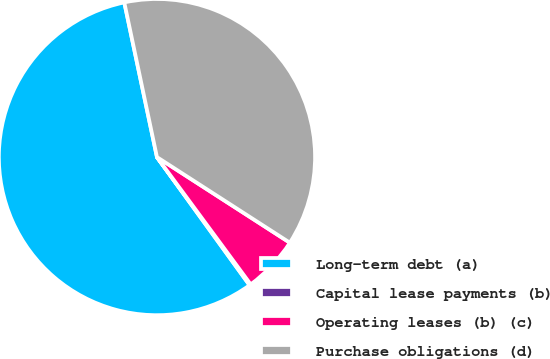Convert chart. <chart><loc_0><loc_0><loc_500><loc_500><pie_chart><fcel>Long-term debt (a)<fcel>Capital lease payments (b)<fcel>Operating leases (b) (c)<fcel>Purchase obligations (d)<nl><fcel>56.65%<fcel>0.14%<fcel>5.79%<fcel>37.42%<nl></chart> 